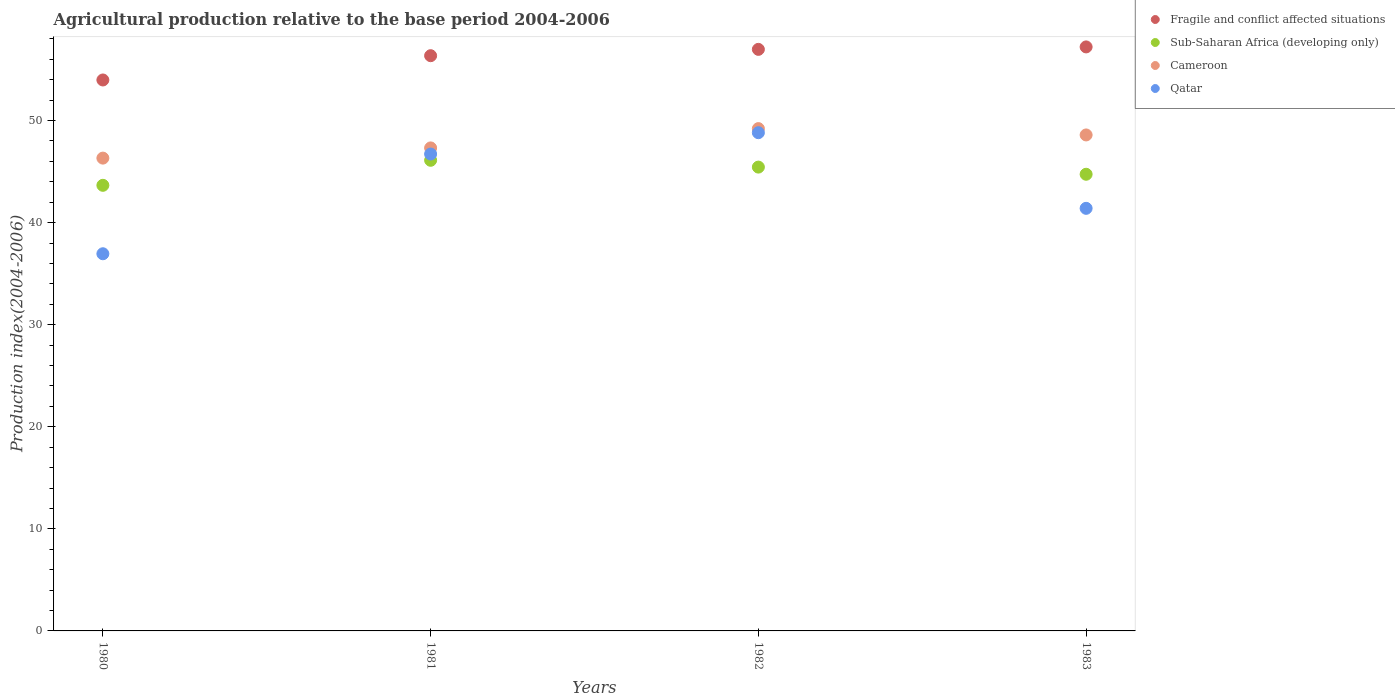What is the agricultural production index in Cameroon in 1982?
Make the answer very short. 49.21. Across all years, what is the maximum agricultural production index in Fragile and conflict affected situations?
Offer a terse response. 57.21. Across all years, what is the minimum agricultural production index in Fragile and conflict affected situations?
Your answer should be compact. 53.98. In which year was the agricultural production index in Fragile and conflict affected situations minimum?
Keep it short and to the point. 1980. What is the total agricultural production index in Fragile and conflict affected situations in the graph?
Make the answer very short. 224.52. What is the difference between the agricultural production index in Qatar in 1980 and that in 1983?
Keep it short and to the point. -4.45. What is the difference between the agricultural production index in Cameroon in 1983 and the agricultural production index in Qatar in 1981?
Offer a terse response. 1.87. What is the average agricultural production index in Qatar per year?
Make the answer very short. 43.47. In the year 1983, what is the difference between the agricultural production index in Cameroon and agricultural production index in Sub-Saharan Africa (developing only)?
Make the answer very short. 3.85. What is the ratio of the agricultural production index in Sub-Saharan Africa (developing only) in 1980 to that in 1983?
Your response must be concise. 0.98. Is the difference between the agricultural production index in Cameroon in 1980 and 1982 greater than the difference between the agricultural production index in Sub-Saharan Africa (developing only) in 1980 and 1982?
Offer a very short reply. No. What is the difference between the highest and the second highest agricultural production index in Sub-Saharan Africa (developing only)?
Your answer should be compact. 0.67. What is the difference between the highest and the lowest agricultural production index in Cameroon?
Provide a short and direct response. 2.89. In how many years, is the agricultural production index in Cameroon greater than the average agricultural production index in Cameroon taken over all years?
Your answer should be compact. 2. Is it the case that in every year, the sum of the agricultural production index in Cameroon and agricultural production index in Sub-Saharan Africa (developing only)  is greater than the agricultural production index in Fragile and conflict affected situations?
Keep it short and to the point. Yes. Does the agricultural production index in Cameroon monotonically increase over the years?
Ensure brevity in your answer.  No. Is the agricultural production index in Qatar strictly less than the agricultural production index in Fragile and conflict affected situations over the years?
Ensure brevity in your answer.  Yes. What is the difference between two consecutive major ticks on the Y-axis?
Your response must be concise. 10. How many legend labels are there?
Offer a terse response. 4. How are the legend labels stacked?
Provide a succinct answer. Vertical. What is the title of the graph?
Ensure brevity in your answer.  Agricultural production relative to the base period 2004-2006. Does "Nicaragua" appear as one of the legend labels in the graph?
Offer a terse response. No. What is the label or title of the Y-axis?
Your response must be concise. Production index(2004-2006). What is the Production index(2004-2006) in Fragile and conflict affected situations in 1980?
Make the answer very short. 53.98. What is the Production index(2004-2006) in Sub-Saharan Africa (developing only) in 1980?
Make the answer very short. 43.65. What is the Production index(2004-2006) of Cameroon in 1980?
Your answer should be compact. 46.32. What is the Production index(2004-2006) in Qatar in 1980?
Keep it short and to the point. 36.95. What is the Production index(2004-2006) in Fragile and conflict affected situations in 1981?
Give a very brief answer. 56.35. What is the Production index(2004-2006) in Sub-Saharan Africa (developing only) in 1981?
Offer a terse response. 46.11. What is the Production index(2004-2006) in Cameroon in 1981?
Your answer should be compact. 47.32. What is the Production index(2004-2006) of Qatar in 1981?
Keep it short and to the point. 46.72. What is the Production index(2004-2006) of Fragile and conflict affected situations in 1982?
Your response must be concise. 56.97. What is the Production index(2004-2006) in Sub-Saharan Africa (developing only) in 1982?
Give a very brief answer. 45.44. What is the Production index(2004-2006) in Cameroon in 1982?
Provide a succinct answer. 49.21. What is the Production index(2004-2006) of Qatar in 1982?
Provide a succinct answer. 48.81. What is the Production index(2004-2006) of Fragile and conflict affected situations in 1983?
Offer a terse response. 57.21. What is the Production index(2004-2006) in Sub-Saharan Africa (developing only) in 1983?
Offer a very short reply. 44.74. What is the Production index(2004-2006) in Cameroon in 1983?
Give a very brief answer. 48.59. What is the Production index(2004-2006) of Qatar in 1983?
Offer a terse response. 41.4. Across all years, what is the maximum Production index(2004-2006) of Fragile and conflict affected situations?
Offer a terse response. 57.21. Across all years, what is the maximum Production index(2004-2006) of Sub-Saharan Africa (developing only)?
Offer a very short reply. 46.11. Across all years, what is the maximum Production index(2004-2006) in Cameroon?
Offer a very short reply. 49.21. Across all years, what is the maximum Production index(2004-2006) of Qatar?
Give a very brief answer. 48.81. Across all years, what is the minimum Production index(2004-2006) in Fragile and conflict affected situations?
Offer a very short reply. 53.98. Across all years, what is the minimum Production index(2004-2006) of Sub-Saharan Africa (developing only)?
Give a very brief answer. 43.65. Across all years, what is the minimum Production index(2004-2006) of Cameroon?
Ensure brevity in your answer.  46.32. Across all years, what is the minimum Production index(2004-2006) of Qatar?
Your answer should be compact. 36.95. What is the total Production index(2004-2006) in Fragile and conflict affected situations in the graph?
Provide a short and direct response. 224.52. What is the total Production index(2004-2006) in Sub-Saharan Africa (developing only) in the graph?
Provide a succinct answer. 179.94. What is the total Production index(2004-2006) of Cameroon in the graph?
Ensure brevity in your answer.  191.44. What is the total Production index(2004-2006) in Qatar in the graph?
Offer a terse response. 173.88. What is the difference between the Production index(2004-2006) of Fragile and conflict affected situations in 1980 and that in 1981?
Provide a succinct answer. -2.38. What is the difference between the Production index(2004-2006) in Sub-Saharan Africa (developing only) in 1980 and that in 1981?
Keep it short and to the point. -2.45. What is the difference between the Production index(2004-2006) in Cameroon in 1980 and that in 1981?
Your response must be concise. -1. What is the difference between the Production index(2004-2006) of Qatar in 1980 and that in 1981?
Make the answer very short. -9.77. What is the difference between the Production index(2004-2006) of Fragile and conflict affected situations in 1980 and that in 1982?
Offer a terse response. -3. What is the difference between the Production index(2004-2006) in Sub-Saharan Africa (developing only) in 1980 and that in 1982?
Give a very brief answer. -1.78. What is the difference between the Production index(2004-2006) of Cameroon in 1980 and that in 1982?
Offer a very short reply. -2.89. What is the difference between the Production index(2004-2006) of Qatar in 1980 and that in 1982?
Offer a terse response. -11.86. What is the difference between the Production index(2004-2006) in Fragile and conflict affected situations in 1980 and that in 1983?
Ensure brevity in your answer.  -3.24. What is the difference between the Production index(2004-2006) of Sub-Saharan Africa (developing only) in 1980 and that in 1983?
Give a very brief answer. -1.08. What is the difference between the Production index(2004-2006) in Cameroon in 1980 and that in 1983?
Make the answer very short. -2.27. What is the difference between the Production index(2004-2006) of Qatar in 1980 and that in 1983?
Offer a terse response. -4.45. What is the difference between the Production index(2004-2006) in Fragile and conflict affected situations in 1981 and that in 1982?
Keep it short and to the point. -0.62. What is the difference between the Production index(2004-2006) in Sub-Saharan Africa (developing only) in 1981 and that in 1982?
Your answer should be compact. 0.67. What is the difference between the Production index(2004-2006) of Cameroon in 1981 and that in 1982?
Make the answer very short. -1.89. What is the difference between the Production index(2004-2006) in Qatar in 1981 and that in 1982?
Provide a short and direct response. -2.09. What is the difference between the Production index(2004-2006) in Fragile and conflict affected situations in 1981 and that in 1983?
Make the answer very short. -0.86. What is the difference between the Production index(2004-2006) of Sub-Saharan Africa (developing only) in 1981 and that in 1983?
Make the answer very short. 1.37. What is the difference between the Production index(2004-2006) in Cameroon in 1981 and that in 1983?
Your answer should be compact. -1.27. What is the difference between the Production index(2004-2006) of Qatar in 1981 and that in 1983?
Ensure brevity in your answer.  5.32. What is the difference between the Production index(2004-2006) in Fragile and conflict affected situations in 1982 and that in 1983?
Offer a terse response. -0.24. What is the difference between the Production index(2004-2006) of Sub-Saharan Africa (developing only) in 1982 and that in 1983?
Your answer should be compact. 0.7. What is the difference between the Production index(2004-2006) in Cameroon in 1982 and that in 1983?
Offer a terse response. 0.62. What is the difference between the Production index(2004-2006) of Qatar in 1982 and that in 1983?
Offer a very short reply. 7.41. What is the difference between the Production index(2004-2006) of Fragile and conflict affected situations in 1980 and the Production index(2004-2006) of Sub-Saharan Africa (developing only) in 1981?
Offer a terse response. 7.87. What is the difference between the Production index(2004-2006) in Fragile and conflict affected situations in 1980 and the Production index(2004-2006) in Cameroon in 1981?
Your answer should be compact. 6.66. What is the difference between the Production index(2004-2006) in Fragile and conflict affected situations in 1980 and the Production index(2004-2006) in Qatar in 1981?
Give a very brief answer. 7.26. What is the difference between the Production index(2004-2006) in Sub-Saharan Africa (developing only) in 1980 and the Production index(2004-2006) in Cameroon in 1981?
Provide a succinct answer. -3.67. What is the difference between the Production index(2004-2006) of Sub-Saharan Africa (developing only) in 1980 and the Production index(2004-2006) of Qatar in 1981?
Provide a short and direct response. -3.07. What is the difference between the Production index(2004-2006) in Fragile and conflict affected situations in 1980 and the Production index(2004-2006) in Sub-Saharan Africa (developing only) in 1982?
Your answer should be compact. 8.54. What is the difference between the Production index(2004-2006) in Fragile and conflict affected situations in 1980 and the Production index(2004-2006) in Cameroon in 1982?
Your answer should be compact. 4.77. What is the difference between the Production index(2004-2006) in Fragile and conflict affected situations in 1980 and the Production index(2004-2006) in Qatar in 1982?
Offer a very short reply. 5.17. What is the difference between the Production index(2004-2006) in Sub-Saharan Africa (developing only) in 1980 and the Production index(2004-2006) in Cameroon in 1982?
Provide a short and direct response. -5.56. What is the difference between the Production index(2004-2006) in Sub-Saharan Africa (developing only) in 1980 and the Production index(2004-2006) in Qatar in 1982?
Give a very brief answer. -5.16. What is the difference between the Production index(2004-2006) of Cameroon in 1980 and the Production index(2004-2006) of Qatar in 1982?
Give a very brief answer. -2.49. What is the difference between the Production index(2004-2006) in Fragile and conflict affected situations in 1980 and the Production index(2004-2006) in Sub-Saharan Africa (developing only) in 1983?
Provide a succinct answer. 9.24. What is the difference between the Production index(2004-2006) of Fragile and conflict affected situations in 1980 and the Production index(2004-2006) of Cameroon in 1983?
Provide a short and direct response. 5.39. What is the difference between the Production index(2004-2006) in Fragile and conflict affected situations in 1980 and the Production index(2004-2006) in Qatar in 1983?
Offer a terse response. 12.58. What is the difference between the Production index(2004-2006) in Sub-Saharan Africa (developing only) in 1980 and the Production index(2004-2006) in Cameroon in 1983?
Your answer should be very brief. -4.94. What is the difference between the Production index(2004-2006) of Sub-Saharan Africa (developing only) in 1980 and the Production index(2004-2006) of Qatar in 1983?
Provide a succinct answer. 2.25. What is the difference between the Production index(2004-2006) of Cameroon in 1980 and the Production index(2004-2006) of Qatar in 1983?
Give a very brief answer. 4.92. What is the difference between the Production index(2004-2006) in Fragile and conflict affected situations in 1981 and the Production index(2004-2006) in Sub-Saharan Africa (developing only) in 1982?
Offer a very short reply. 10.91. What is the difference between the Production index(2004-2006) of Fragile and conflict affected situations in 1981 and the Production index(2004-2006) of Cameroon in 1982?
Your response must be concise. 7.14. What is the difference between the Production index(2004-2006) of Fragile and conflict affected situations in 1981 and the Production index(2004-2006) of Qatar in 1982?
Your answer should be very brief. 7.54. What is the difference between the Production index(2004-2006) of Sub-Saharan Africa (developing only) in 1981 and the Production index(2004-2006) of Cameroon in 1982?
Offer a very short reply. -3.1. What is the difference between the Production index(2004-2006) of Sub-Saharan Africa (developing only) in 1981 and the Production index(2004-2006) of Qatar in 1982?
Offer a very short reply. -2.7. What is the difference between the Production index(2004-2006) in Cameroon in 1981 and the Production index(2004-2006) in Qatar in 1982?
Ensure brevity in your answer.  -1.49. What is the difference between the Production index(2004-2006) in Fragile and conflict affected situations in 1981 and the Production index(2004-2006) in Sub-Saharan Africa (developing only) in 1983?
Offer a very short reply. 11.62. What is the difference between the Production index(2004-2006) of Fragile and conflict affected situations in 1981 and the Production index(2004-2006) of Cameroon in 1983?
Give a very brief answer. 7.76. What is the difference between the Production index(2004-2006) in Fragile and conflict affected situations in 1981 and the Production index(2004-2006) in Qatar in 1983?
Offer a very short reply. 14.95. What is the difference between the Production index(2004-2006) in Sub-Saharan Africa (developing only) in 1981 and the Production index(2004-2006) in Cameroon in 1983?
Your response must be concise. -2.48. What is the difference between the Production index(2004-2006) in Sub-Saharan Africa (developing only) in 1981 and the Production index(2004-2006) in Qatar in 1983?
Offer a very short reply. 4.71. What is the difference between the Production index(2004-2006) of Cameroon in 1981 and the Production index(2004-2006) of Qatar in 1983?
Keep it short and to the point. 5.92. What is the difference between the Production index(2004-2006) in Fragile and conflict affected situations in 1982 and the Production index(2004-2006) in Sub-Saharan Africa (developing only) in 1983?
Keep it short and to the point. 12.24. What is the difference between the Production index(2004-2006) in Fragile and conflict affected situations in 1982 and the Production index(2004-2006) in Cameroon in 1983?
Keep it short and to the point. 8.38. What is the difference between the Production index(2004-2006) in Fragile and conflict affected situations in 1982 and the Production index(2004-2006) in Qatar in 1983?
Offer a very short reply. 15.57. What is the difference between the Production index(2004-2006) in Sub-Saharan Africa (developing only) in 1982 and the Production index(2004-2006) in Cameroon in 1983?
Offer a very short reply. -3.15. What is the difference between the Production index(2004-2006) in Sub-Saharan Africa (developing only) in 1982 and the Production index(2004-2006) in Qatar in 1983?
Make the answer very short. 4.04. What is the difference between the Production index(2004-2006) of Cameroon in 1982 and the Production index(2004-2006) of Qatar in 1983?
Your answer should be compact. 7.81. What is the average Production index(2004-2006) in Fragile and conflict affected situations per year?
Keep it short and to the point. 56.13. What is the average Production index(2004-2006) of Sub-Saharan Africa (developing only) per year?
Offer a very short reply. 44.98. What is the average Production index(2004-2006) of Cameroon per year?
Ensure brevity in your answer.  47.86. What is the average Production index(2004-2006) of Qatar per year?
Give a very brief answer. 43.47. In the year 1980, what is the difference between the Production index(2004-2006) of Fragile and conflict affected situations and Production index(2004-2006) of Sub-Saharan Africa (developing only)?
Make the answer very short. 10.32. In the year 1980, what is the difference between the Production index(2004-2006) of Fragile and conflict affected situations and Production index(2004-2006) of Cameroon?
Provide a succinct answer. 7.66. In the year 1980, what is the difference between the Production index(2004-2006) of Fragile and conflict affected situations and Production index(2004-2006) of Qatar?
Keep it short and to the point. 17.03. In the year 1980, what is the difference between the Production index(2004-2006) in Sub-Saharan Africa (developing only) and Production index(2004-2006) in Cameroon?
Give a very brief answer. -2.67. In the year 1980, what is the difference between the Production index(2004-2006) of Sub-Saharan Africa (developing only) and Production index(2004-2006) of Qatar?
Offer a very short reply. 6.7. In the year 1980, what is the difference between the Production index(2004-2006) in Cameroon and Production index(2004-2006) in Qatar?
Your response must be concise. 9.37. In the year 1981, what is the difference between the Production index(2004-2006) in Fragile and conflict affected situations and Production index(2004-2006) in Sub-Saharan Africa (developing only)?
Ensure brevity in your answer.  10.25. In the year 1981, what is the difference between the Production index(2004-2006) in Fragile and conflict affected situations and Production index(2004-2006) in Cameroon?
Your answer should be very brief. 9.03. In the year 1981, what is the difference between the Production index(2004-2006) of Fragile and conflict affected situations and Production index(2004-2006) of Qatar?
Offer a terse response. 9.63. In the year 1981, what is the difference between the Production index(2004-2006) in Sub-Saharan Africa (developing only) and Production index(2004-2006) in Cameroon?
Your answer should be very brief. -1.21. In the year 1981, what is the difference between the Production index(2004-2006) in Sub-Saharan Africa (developing only) and Production index(2004-2006) in Qatar?
Give a very brief answer. -0.61. In the year 1981, what is the difference between the Production index(2004-2006) of Cameroon and Production index(2004-2006) of Qatar?
Your answer should be very brief. 0.6. In the year 1982, what is the difference between the Production index(2004-2006) of Fragile and conflict affected situations and Production index(2004-2006) of Sub-Saharan Africa (developing only)?
Ensure brevity in your answer.  11.53. In the year 1982, what is the difference between the Production index(2004-2006) of Fragile and conflict affected situations and Production index(2004-2006) of Cameroon?
Your response must be concise. 7.76. In the year 1982, what is the difference between the Production index(2004-2006) in Fragile and conflict affected situations and Production index(2004-2006) in Qatar?
Your answer should be compact. 8.16. In the year 1982, what is the difference between the Production index(2004-2006) in Sub-Saharan Africa (developing only) and Production index(2004-2006) in Cameroon?
Provide a short and direct response. -3.77. In the year 1982, what is the difference between the Production index(2004-2006) in Sub-Saharan Africa (developing only) and Production index(2004-2006) in Qatar?
Offer a terse response. -3.37. In the year 1982, what is the difference between the Production index(2004-2006) in Cameroon and Production index(2004-2006) in Qatar?
Your answer should be very brief. 0.4. In the year 1983, what is the difference between the Production index(2004-2006) of Fragile and conflict affected situations and Production index(2004-2006) of Sub-Saharan Africa (developing only)?
Your answer should be very brief. 12.48. In the year 1983, what is the difference between the Production index(2004-2006) of Fragile and conflict affected situations and Production index(2004-2006) of Cameroon?
Keep it short and to the point. 8.62. In the year 1983, what is the difference between the Production index(2004-2006) of Fragile and conflict affected situations and Production index(2004-2006) of Qatar?
Offer a terse response. 15.81. In the year 1983, what is the difference between the Production index(2004-2006) in Sub-Saharan Africa (developing only) and Production index(2004-2006) in Cameroon?
Your response must be concise. -3.85. In the year 1983, what is the difference between the Production index(2004-2006) in Sub-Saharan Africa (developing only) and Production index(2004-2006) in Qatar?
Ensure brevity in your answer.  3.34. In the year 1983, what is the difference between the Production index(2004-2006) of Cameroon and Production index(2004-2006) of Qatar?
Provide a succinct answer. 7.19. What is the ratio of the Production index(2004-2006) of Fragile and conflict affected situations in 1980 to that in 1981?
Ensure brevity in your answer.  0.96. What is the ratio of the Production index(2004-2006) of Sub-Saharan Africa (developing only) in 1980 to that in 1981?
Offer a very short reply. 0.95. What is the ratio of the Production index(2004-2006) of Cameroon in 1980 to that in 1981?
Your answer should be very brief. 0.98. What is the ratio of the Production index(2004-2006) of Qatar in 1980 to that in 1981?
Ensure brevity in your answer.  0.79. What is the ratio of the Production index(2004-2006) of Fragile and conflict affected situations in 1980 to that in 1982?
Your answer should be very brief. 0.95. What is the ratio of the Production index(2004-2006) in Sub-Saharan Africa (developing only) in 1980 to that in 1982?
Your response must be concise. 0.96. What is the ratio of the Production index(2004-2006) of Cameroon in 1980 to that in 1982?
Your answer should be very brief. 0.94. What is the ratio of the Production index(2004-2006) of Qatar in 1980 to that in 1982?
Provide a short and direct response. 0.76. What is the ratio of the Production index(2004-2006) of Fragile and conflict affected situations in 1980 to that in 1983?
Offer a very short reply. 0.94. What is the ratio of the Production index(2004-2006) of Sub-Saharan Africa (developing only) in 1980 to that in 1983?
Your answer should be very brief. 0.98. What is the ratio of the Production index(2004-2006) in Cameroon in 1980 to that in 1983?
Keep it short and to the point. 0.95. What is the ratio of the Production index(2004-2006) of Qatar in 1980 to that in 1983?
Give a very brief answer. 0.89. What is the ratio of the Production index(2004-2006) of Sub-Saharan Africa (developing only) in 1981 to that in 1982?
Keep it short and to the point. 1.01. What is the ratio of the Production index(2004-2006) of Cameroon in 1981 to that in 1982?
Provide a short and direct response. 0.96. What is the ratio of the Production index(2004-2006) in Qatar in 1981 to that in 1982?
Offer a terse response. 0.96. What is the ratio of the Production index(2004-2006) of Fragile and conflict affected situations in 1981 to that in 1983?
Keep it short and to the point. 0.98. What is the ratio of the Production index(2004-2006) of Sub-Saharan Africa (developing only) in 1981 to that in 1983?
Make the answer very short. 1.03. What is the ratio of the Production index(2004-2006) of Cameroon in 1981 to that in 1983?
Offer a terse response. 0.97. What is the ratio of the Production index(2004-2006) in Qatar in 1981 to that in 1983?
Offer a very short reply. 1.13. What is the ratio of the Production index(2004-2006) in Sub-Saharan Africa (developing only) in 1982 to that in 1983?
Ensure brevity in your answer.  1.02. What is the ratio of the Production index(2004-2006) in Cameroon in 1982 to that in 1983?
Give a very brief answer. 1.01. What is the ratio of the Production index(2004-2006) of Qatar in 1982 to that in 1983?
Offer a very short reply. 1.18. What is the difference between the highest and the second highest Production index(2004-2006) of Fragile and conflict affected situations?
Your response must be concise. 0.24. What is the difference between the highest and the second highest Production index(2004-2006) of Sub-Saharan Africa (developing only)?
Your answer should be very brief. 0.67. What is the difference between the highest and the second highest Production index(2004-2006) of Cameroon?
Give a very brief answer. 0.62. What is the difference between the highest and the second highest Production index(2004-2006) in Qatar?
Offer a very short reply. 2.09. What is the difference between the highest and the lowest Production index(2004-2006) in Fragile and conflict affected situations?
Ensure brevity in your answer.  3.24. What is the difference between the highest and the lowest Production index(2004-2006) in Sub-Saharan Africa (developing only)?
Keep it short and to the point. 2.45. What is the difference between the highest and the lowest Production index(2004-2006) of Cameroon?
Make the answer very short. 2.89. What is the difference between the highest and the lowest Production index(2004-2006) in Qatar?
Provide a short and direct response. 11.86. 